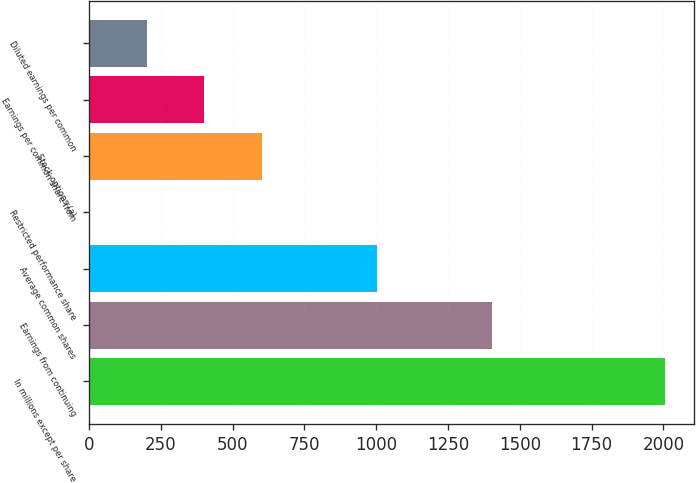<chart> <loc_0><loc_0><loc_500><loc_500><bar_chart><fcel>In millions except per share<fcel>Earnings from continuing<fcel>Average common shares<fcel>Restricted performance share<fcel>Stock options (a)<fcel>Earnings per common share from<fcel>Diluted earnings per common<nl><fcel>2005<fcel>1403.74<fcel>1002.9<fcel>0.8<fcel>602.06<fcel>401.64<fcel>201.22<nl></chart> 